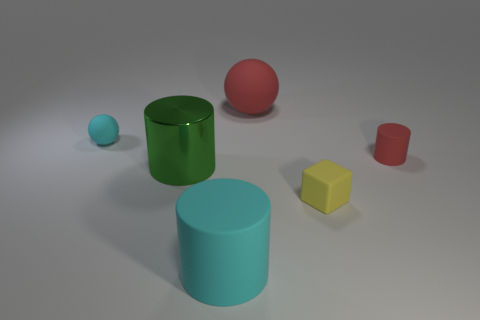The red cylinder is what size?
Your answer should be very brief. Small. Is the material of the red cylinder the same as the tiny sphere?
Make the answer very short. Yes. How many red cylinders are right of the large rubber thing that is behind the cyan matte thing in front of the yellow rubber object?
Make the answer very short. 1. The tiny object on the left side of the small yellow object has what shape?
Give a very brief answer. Sphere. What number of other objects are the same material as the big sphere?
Provide a succinct answer. 4. Is the color of the small cylinder the same as the large ball?
Ensure brevity in your answer.  Yes. Is the number of small matte things in front of the green metal thing less than the number of large cyan objects that are right of the red ball?
Your answer should be compact. No. There is a tiny rubber object that is the same shape as the big green shiny thing; what color is it?
Ensure brevity in your answer.  Red. Does the cyan rubber object that is to the right of the metallic cylinder have the same size as the green object?
Your answer should be compact. Yes. Are there fewer green shiny cylinders that are left of the cyan sphere than balls?
Your answer should be very brief. Yes. 